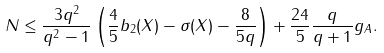<formula> <loc_0><loc_0><loc_500><loc_500>N \leq \frac { 3 q ^ { 2 } } { q ^ { 2 } - 1 } \left ( \frac { 4 } { 5 } b _ { 2 } ( X ) - \sigma ( X ) - \frac { 8 } { 5 q } \right ) + \frac { 2 4 } { 5 } \frac { q } { q + 1 } g _ { A } .</formula> 